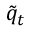<formula> <loc_0><loc_0><loc_500><loc_500>{ \tilde { q } } _ { t }</formula> 